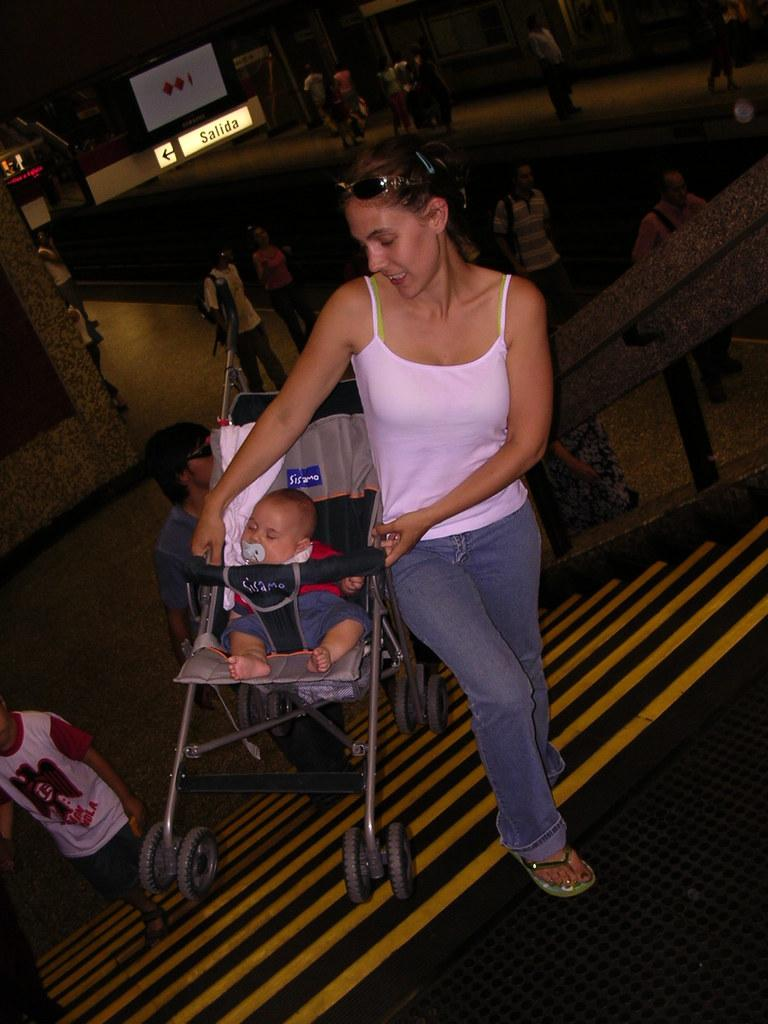<image>
Present a compact description of the photo's key features. the word salida that is near a person 